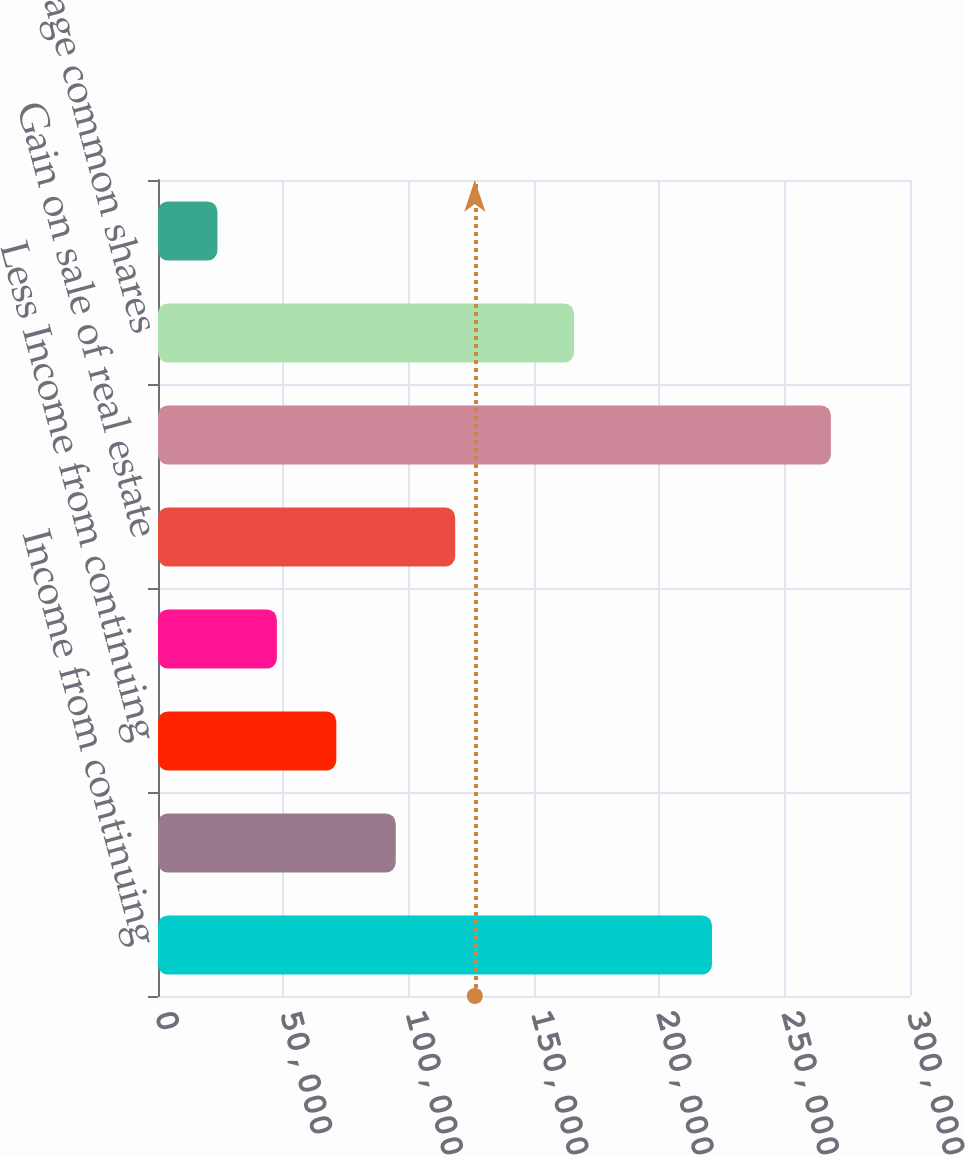<chart> <loc_0><loc_0><loc_500><loc_500><bar_chart><fcel>Income from continuing<fcel>Less Preferred share dividends<fcel>Less Income from continuing<fcel>Less Earnings allocated to<fcel>Gain on sale of real estate<fcel>Net income available for<fcel>Weighted average common shares<fcel>Stock options<nl><fcel>221020<fcel>94846.3<fcel>71135.5<fcel>47424.7<fcel>118557<fcel>268442<fcel>165979<fcel>23714<nl></chart> 